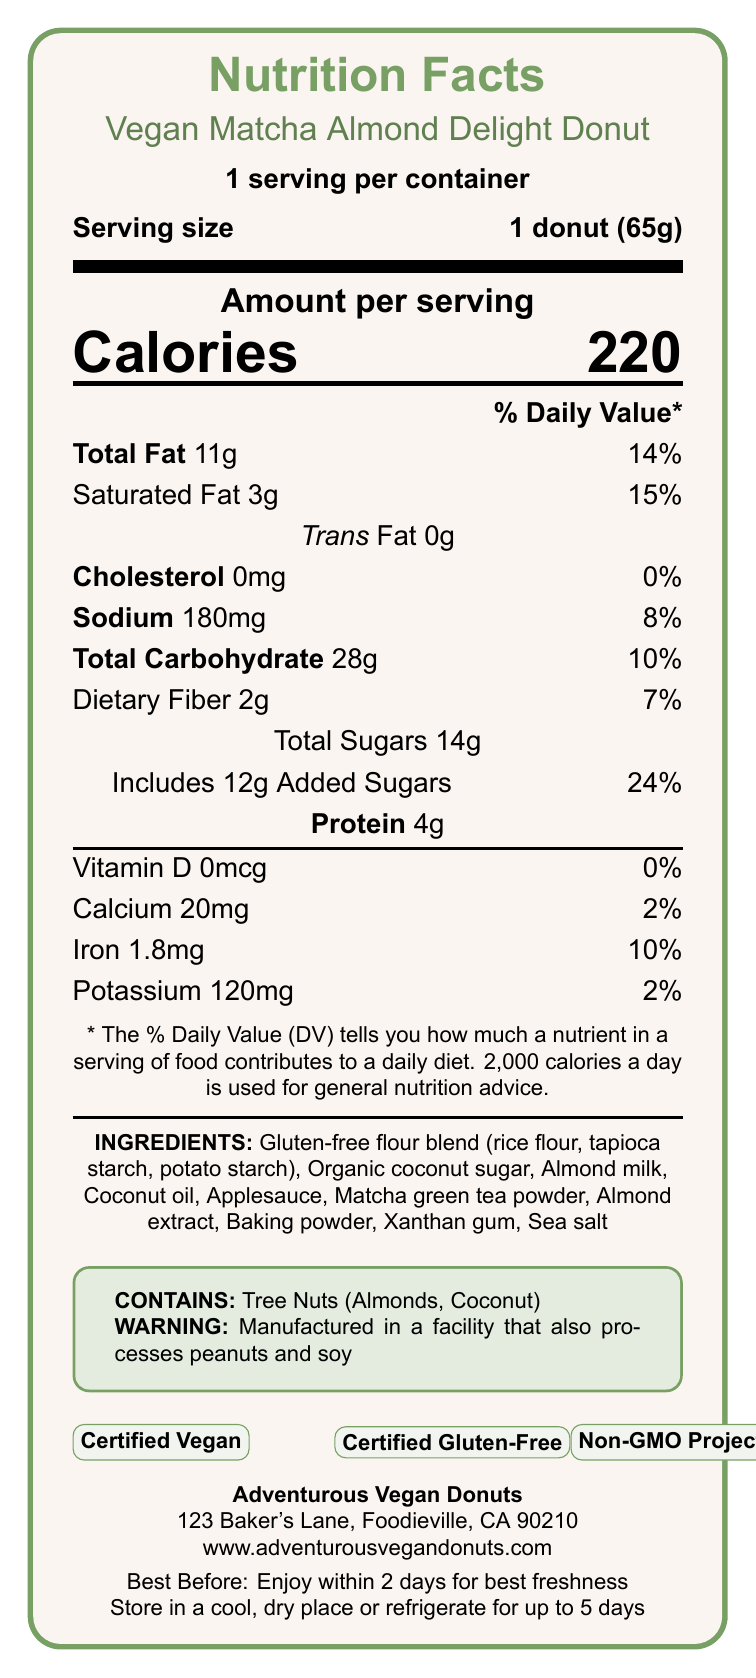what is the serving size of the Vegan Matcha Almond Delight Donut? The serving size is clearly stated as "1 donut (65g)" in the document.
Answer: 1 donut (65g) how many calories are in one serving of the donut? The document shows "Calories: 220" under the "Amount per serving" section.
Answer: 220 what is the percentage of the daily value for total fat in one donut? The document indicates "Total Fat 11g" with "14%" listed alongside it in the nutritional breakdown.
Answer: 14% what are the ingredients in the Vegan Matcha Almond Delight Donut? The ingredients are listed under the "INGREDIENTS:" section.
Answer: Gluten-free flour blend (rice flour, tapioca starch, potato starch), Organic coconut sugar, Almond milk, Coconut oil, Applesauce, Matcha green tea powder, Almond extract, Baking powder, Xanthan gum, Sea salt does the donut contain any tree nuts? The allergen statement clearly indicates "Contains: Tree Nuts (Almonds, Coconut)".
Answer: Yes how much protein is in one donut? The document shows "Protein: 4g" under the nutritional information.
Answer: 4g what is the certification status of the donut regarding gluten? A. Gluten-Free B. Contains Gluten C. Not Certified The document states that the donut is "Certified Gluten-Free".
Answer: A. Gluten-Free how much added sugar is in one serving of the donut? A. 12g B. 14g C. 0g The added sugars amount is specified as "Includes 12g Added Sugars".
Answer: A. 12g is the donut high in iron? The document states the donut contains 1.8mg of iron which is 10% of the Daily Value, but it does not claim "high in iron"; it only states "Good source of iron".
Answer: No what is the best condition to store the donut for extended freshness? The storage instructions specify to "store in a cool, dry place or refrigerate for up to 5 days".
Answer: Store in a cool, dry place or refrigerate for up to 5 days describe the entire document The document provides detailed nutritional and product information about the "Vegan Matcha Almond Delight Donut", highlighting its vegan and gluten-free attributes, ingredient list, nutritional values, and storage instructions.
Answer: The document is a Nutrition Facts Label for the "Vegan Matcha Almond Delight Donut". It details the serving size, calorie count, and breakdown of nutritional information including fats, sodium, carbohydrates, fibers, sugars, and proteins. It includes an allergen statement that mentions the presence of almonds and coconut and a warning about manufacturing conditions. The document highlights certifications such as Vegan, Gluten-Free, and Non-GMO. It also lists the ingredients, nutritional highlights, special features, manufacturer information, best-before date, and storage instructions. where can you find more information about the manufacturer of the donut? Manufacturer information is located at the bottom of the document including the name, address, and website.
Answer: Adventurous Vegan Donuts, 123 Baker's Lane, Foodieville, CA 90210, www.adventurousvegandonuts.com does the donut contain any cholesterol? The document specifies "Cholesterol 0mg 0%" in the nutritional information.
Answer: No which ingredients in the donut are organic? The section labeled "organicIngredients" lists these two items as organic.
Answer: Coconut sugar, Matcha green tea powder does this document provide information on fiber content? The document specifies "Dietary Fiber 2g 7%" in the nutritional details.
Answer: Yes what is the total sugar content of this donut per serving? The nutritional facts list "Total Sugars 14g" under the carbohydrate section.
Answer: 14g how much calcium does one donut contain? The document specifies "Calcium 20mg" in the nutritional information.
Answer: 20mg is there any mention of vitamin A content in the donut? The document does not provide any information about vitamin A content in the donut.
Answer: No what percentages of daily values are encoded for sodium and potassium respectively? A. 8% and 2% B. 14% and 10% C. 15% and 24% The nutritional information specifies "Sodium 180mg 8%" and "Potassium 120mg 2%".
Answer: A. 8% and 2% how many days after baking should the donut be consumed for best freshness? The document advises "Enjoy within 2 days for best freshness".
Answer: 2 days 